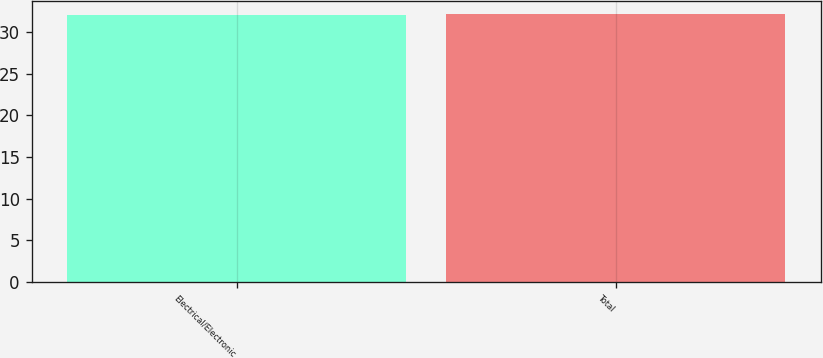Convert chart to OTSL. <chart><loc_0><loc_0><loc_500><loc_500><bar_chart><fcel>Electrical/Electronic<fcel>Total<nl><fcel>32<fcel>32.1<nl></chart> 